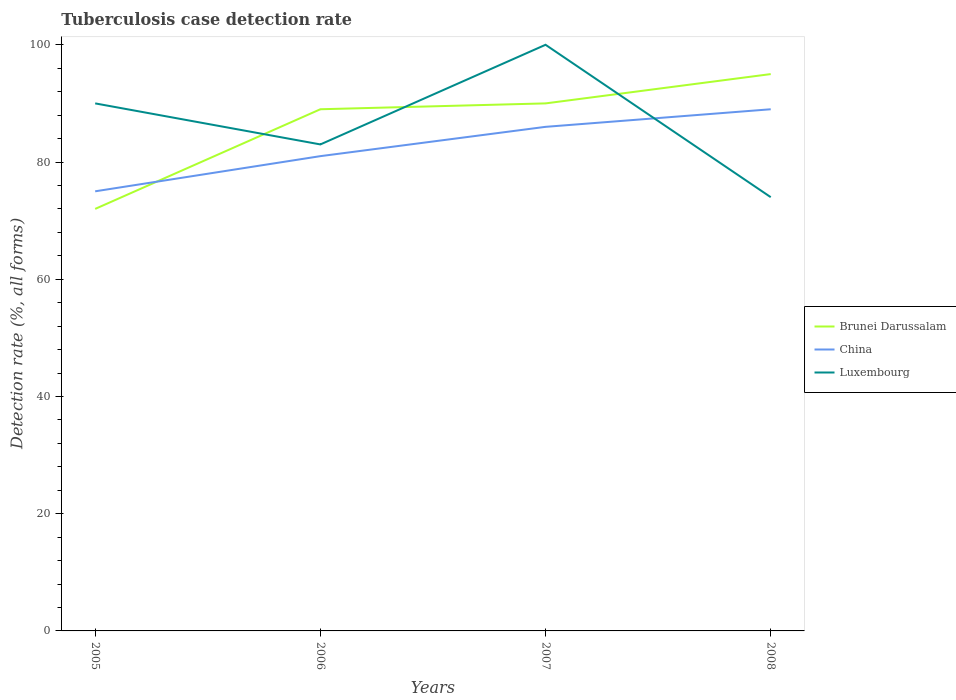Is the number of lines equal to the number of legend labels?
Your answer should be very brief. Yes. What is the total tuberculosis case detection rate in in China in the graph?
Offer a terse response. -14. What is the difference between the highest and the second highest tuberculosis case detection rate in in China?
Your answer should be compact. 14. Is the tuberculosis case detection rate in in China strictly greater than the tuberculosis case detection rate in in Luxembourg over the years?
Provide a short and direct response. No. What is the difference between two consecutive major ticks on the Y-axis?
Your response must be concise. 20. Are the values on the major ticks of Y-axis written in scientific E-notation?
Your answer should be compact. No. Does the graph contain any zero values?
Give a very brief answer. No. Does the graph contain grids?
Your answer should be very brief. No. Where does the legend appear in the graph?
Offer a very short reply. Center right. What is the title of the graph?
Ensure brevity in your answer.  Tuberculosis case detection rate. What is the label or title of the X-axis?
Provide a short and direct response. Years. What is the label or title of the Y-axis?
Offer a terse response. Detection rate (%, all forms). What is the Detection rate (%, all forms) of Brunei Darussalam in 2005?
Make the answer very short. 72. What is the Detection rate (%, all forms) in China in 2005?
Provide a short and direct response. 75. What is the Detection rate (%, all forms) of Luxembourg in 2005?
Your answer should be very brief. 90. What is the Detection rate (%, all forms) in Brunei Darussalam in 2006?
Provide a succinct answer. 89. What is the Detection rate (%, all forms) in China in 2006?
Keep it short and to the point. 81. What is the Detection rate (%, all forms) in Luxembourg in 2006?
Keep it short and to the point. 83. What is the Detection rate (%, all forms) of China in 2007?
Your response must be concise. 86. What is the Detection rate (%, all forms) in Luxembourg in 2007?
Offer a terse response. 100. What is the Detection rate (%, all forms) in Brunei Darussalam in 2008?
Make the answer very short. 95. What is the Detection rate (%, all forms) of China in 2008?
Provide a short and direct response. 89. Across all years, what is the maximum Detection rate (%, all forms) in China?
Make the answer very short. 89. Across all years, what is the maximum Detection rate (%, all forms) in Luxembourg?
Make the answer very short. 100. Across all years, what is the minimum Detection rate (%, all forms) in Brunei Darussalam?
Your answer should be very brief. 72. Across all years, what is the minimum Detection rate (%, all forms) of China?
Offer a terse response. 75. Across all years, what is the minimum Detection rate (%, all forms) of Luxembourg?
Offer a terse response. 74. What is the total Detection rate (%, all forms) in Brunei Darussalam in the graph?
Keep it short and to the point. 346. What is the total Detection rate (%, all forms) in China in the graph?
Offer a terse response. 331. What is the total Detection rate (%, all forms) in Luxembourg in the graph?
Your answer should be compact. 347. What is the difference between the Detection rate (%, all forms) in China in 2005 and that in 2006?
Keep it short and to the point. -6. What is the difference between the Detection rate (%, all forms) in Brunei Darussalam in 2005 and that in 2007?
Your answer should be compact. -18. What is the difference between the Detection rate (%, all forms) of Brunei Darussalam in 2005 and that in 2008?
Keep it short and to the point. -23. What is the difference between the Detection rate (%, all forms) in Brunei Darussalam in 2006 and that in 2007?
Offer a very short reply. -1. What is the difference between the Detection rate (%, all forms) in Brunei Darussalam in 2006 and that in 2008?
Give a very brief answer. -6. What is the difference between the Detection rate (%, all forms) of China in 2006 and that in 2008?
Ensure brevity in your answer.  -8. What is the difference between the Detection rate (%, all forms) in Luxembourg in 2006 and that in 2008?
Your answer should be compact. 9. What is the difference between the Detection rate (%, all forms) of Luxembourg in 2007 and that in 2008?
Keep it short and to the point. 26. What is the difference between the Detection rate (%, all forms) in Brunei Darussalam in 2005 and the Detection rate (%, all forms) in Luxembourg in 2006?
Keep it short and to the point. -11. What is the difference between the Detection rate (%, all forms) in Brunei Darussalam in 2005 and the Detection rate (%, all forms) in China in 2008?
Keep it short and to the point. -17. What is the difference between the Detection rate (%, all forms) of Brunei Darussalam in 2005 and the Detection rate (%, all forms) of Luxembourg in 2008?
Offer a very short reply. -2. What is the difference between the Detection rate (%, all forms) in China in 2005 and the Detection rate (%, all forms) in Luxembourg in 2008?
Offer a very short reply. 1. What is the difference between the Detection rate (%, all forms) in Brunei Darussalam in 2006 and the Detection rate (%, all forms) in China in 2007?
Offer a very short reply. 3. What is the difference between the Detection rate (%, all forms) in China in 2006 and the Detection rate (%, all forms) in Luxembourg in 2007?
Provide a short and direct response. -19. What is the difference between the Detection rate (%, all forms) of China in 2006 and the Detection rate (%, all forms) of Luxembourg in 2008?
Provide a short and direct response. 7. What is the difference between the Detection rate (%, all forms) of Brunei Darussalam in 2007 and the Detection rate (%, all forms) of China in 2008?
Your response must be concise. 1. What is the difference between the Detection rate (%, all forms) of China in 2007 and the Detection rate (%, all forms) of Luxembourg in 2008?
Offer a terse response. 12. What is the average Detection rate (%, all forms) of Brunei Darussalam per year?
Your response must be concise. 86.5. What is the average Detection rate (%, all forms) in China per year?
Your response must be concise. 82.75. What is the average Detection rate (%, all forms) in Luxembourg per year?
Ensure brevity in your answer.  86.75. In the year 2005, what is the difference between the Detection rate (%, all forms) of China and Detection rate (%, all forms) of Luxembourg?
Ensure brevity in your answer.  -15. In the year 2006, what is the difference between the Detection rate (%, all forms) of Brunei Darussalam and Detection rate (%, all forms) of China?
Ensure brevity in your answer.  8. In the year 2006, what is the difference between the Detection rate (%, all forms) in Brunei Darussalam and Detection rate (%, all forms) in Luxembourg?
Your answer should be compact. 6. In the year 2007, what is the difference between the Detection rate (%, all forms) of Brunei Darussalam and Detection rate (%, all forms) of China?
Ensure brevity in your answer.  4. In the year 2007, what is the difference between the Detection rate (%, all forms) of Brunei Darussalam and Detection rate (%, all forms) of Luxembourg?
Ensure brevity in your answer.  -10. In the year 2008, what is the difference between the Detection rate (%, all forms) in Brunei Darussalam and Detection rate (%, all forms) in Luxembourg?
Your answer should be very brief. 21. In the year 2008, what is the difference between the Detection rate (%, all forms) in China and Detection rate (%, all forms) in Luxembourg?
Offer a terse response. 15. What is the ratio of the Detection rate (%, all forms) in Brunei Darussalam in 2005 to that in 2006?
Provide a short and direct response. 0.81. What is the ratio of the Detection rate (%, all forms) in China in 2005 to that in 2006?
Your response must be concise. 0.93. What is the ratio of the Detection rate (%, all forms) in Luxembourg in 2005 to that in 2006?
Give a very brief answer. 1.08. What is the ratio of the Detection rate (%, all forms) in Brunei Darussalam in 2005 to that in 2007?
Make the answer very short. 0.8. What is the ratio of the Detection rate (%, all forms) of China in 2005 to that in 2007?
Your answer should be very brief. 0.87. What is the ratio of the Detection rate (%, all forms) of Brunei Darussalam in 2005 to that in 2008?
Offer a terse response. 0.76. What is the ratio of the Detection rate (%, all forms) in China in 2005 to that in 2008?
Your response must be concise. 0.84. What is the ratio of the Detection rate (%, all forms) of Luxembourg in 2005 to that in 2008?
Provide a succinct answer. 1.22. What is the ratio of the Detection rate (%, all forms) in Brunei Darussalam in 2006 to that in 2007?
Your response must be concise. 0.99. What is the ratio of the Detection rate (%, all forms) of China in 2006 to that in 2007?
Your answer should be compact. 0.94. What is the ratio of the Detection rate (%, all forms) in Luxembourg in 2006 to that in 2007?
Ensure brevity in your answer.  0.83. What is the ratio of the Detection rate (%, all forms) of Brunei Darussalam in 2006 to that in 2008?
Keep it short and to the point. 0.94. What is the ratio of the Detection rate (%, all forms) of China in 2006 to that in 2008?
Make the answer very short. 0.91. What is the ratio of the Detection rate (%, all forms) in Luxembourg in 2006 to that in 2008?
Offer a terse response. 1.12. What is the ratio of the Detection rate (%, all forms) in China in 2007 to that in 2008?
Offer a terse response. 0.97. What is the ratio of the Detection rate (%, all forms) in Luxembourg in 2007 to that in 2008?
Ensure brevity in your answer.  1.35. What is the difference between the highest and the second highest Detection rate (%, all forms) of China?
Offer a very short reply. 3. What is the difference between the highest and the lowest Detection rate (%, all forms) in China?
Offer a very short reply. 14. What is the difference between the highest and the lowest Detection rate (%, all forms) of Luxembourg?
Offer a very short reply. 26. 